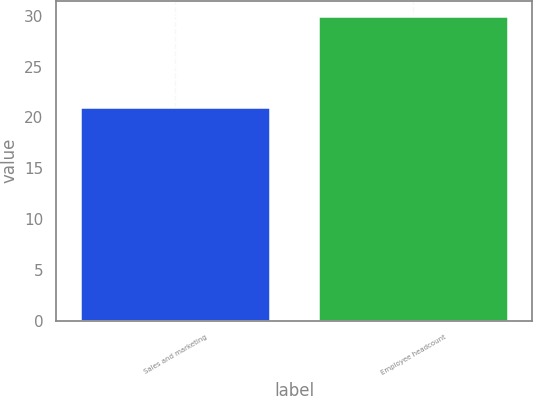<chart> <loc_0><loc_0><loc_500><loc_500><bar_chart><fcel>Sales and marketing<fcel>Employee headcount<nl><fcel>21<fcel>30<nl></chart> 